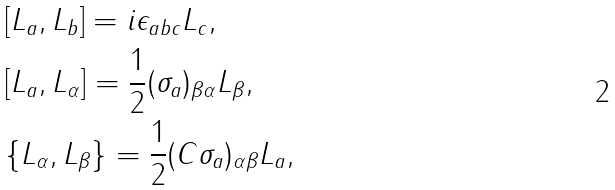Convert formula to latex. <formula><loc_0><loc_0><loc_500><loc_500>& [ L _ { a } , L _ { b } ] = i \epsilon _ { a b c } L _ { c } , \\ & [ L _ { a } , L _ { \alpha } ] = \frac { 1 } { 2 } ( \sigma _ { a } ) _ { \beta \alpha } L _ { \beta } , \\ & \{ L _ { \alpha } , L _ { \beta } \} = \frac { 1 } { 2 } ( C \sigma _ { a } ) _ { \alpha \beta } L _ { a } ,</formula> 